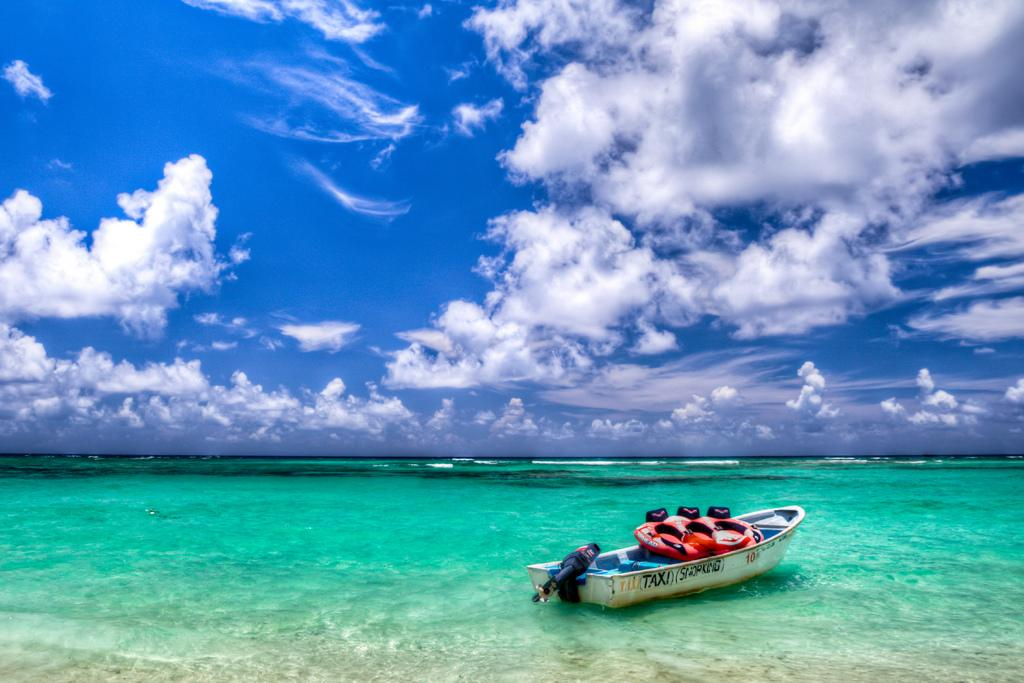What is the main subject of the image? The main subject of the image is a boat. Where is the boat located? The boat is on the water. What can be seen in the background of the image? There is sky visible in the background of the image. What is the condition of the sky in the image? Clouds are present in the sky. How many spots can be seen on the arm of the person in the image? There is no person present in the image, only a boat on the water with clouds in the sky. 